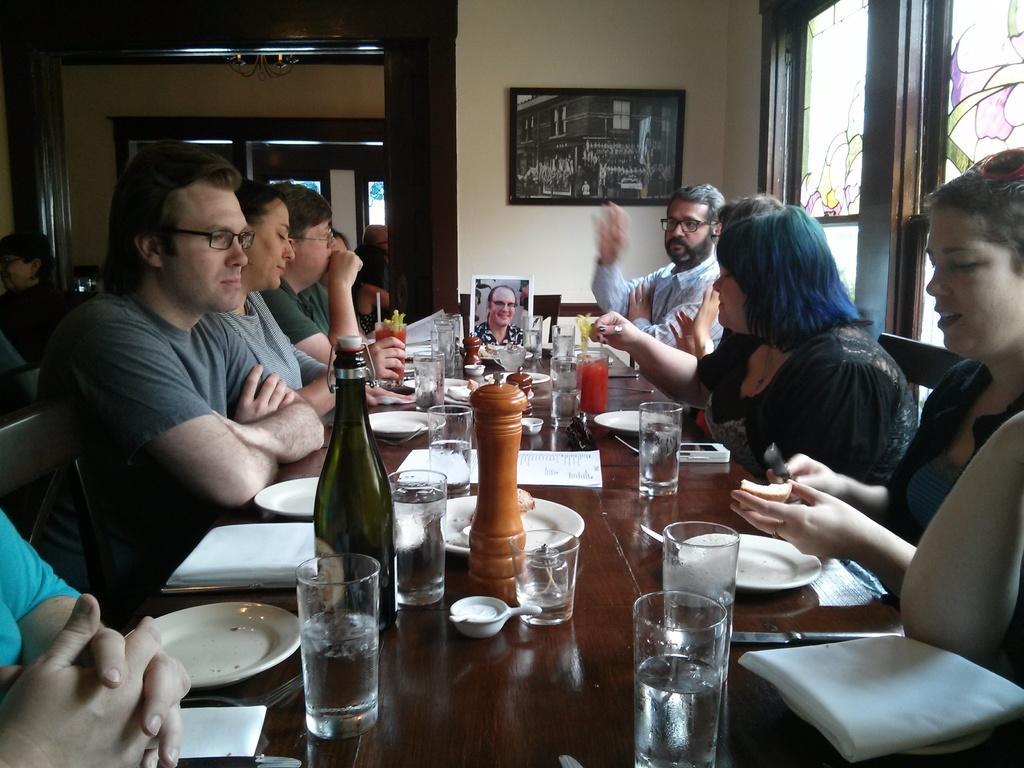In one or two sentences, can you explain what this image depicts? In this image there are group of people sitting in chair near the table and in table there are napkin , glass , photo frame , plate ,a small bowl and in back ground there is a frame attached to a wall, window and door. 